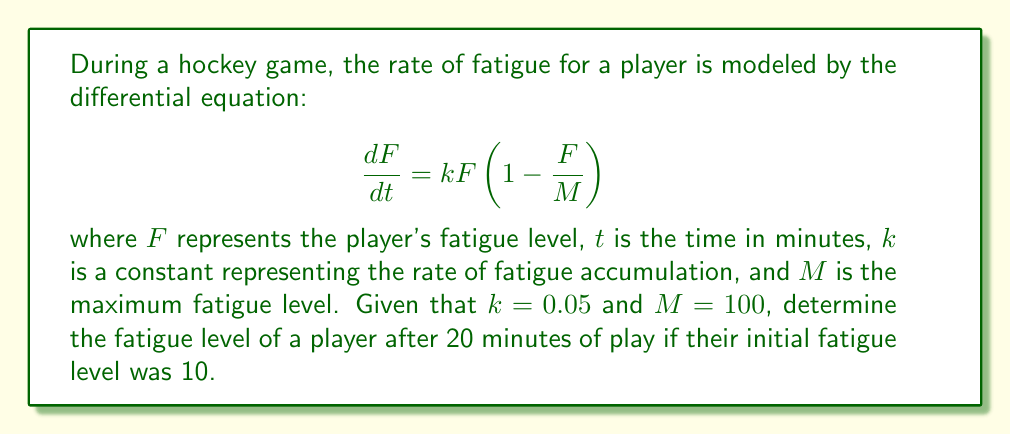Provide a solution to this math problem. To solve this problem, we need to use the given first-order differential equation and apply the separation of variables method:

1) First, let's separate the variables:
   $$ \frac{dF}{F(1-\frac{F}{M})} = k dt $$

2) Integrate both sides:
   $$ \int \frac{dF}{F(1-\frac{F}{M})} = \int k dt $$

3) The left side can be integrated using partial fractions:
   $$ \ln|F| - \ln|M-F| = kt + C $$

4) Simplify:
   $$ \ln|\frac{F}{M-F}| = kt + C $$

5) Exponentiate both sides:
   $$ \frac{F}{M-F} = Ce^{kt} $$

6) Solve for $F$:
   $$ F = \frac{MCe^{kt}}{1+Ce^{kt}} $$

7) Use the initial condition $F(0) = 10$ to find $C$:
   $$ 10 = \frac{100C}{1+C} $$
   $$ C = \frac{1}{9} $$

8) Now we have the particular solution:
   $$ F = \frac{100(\frac{1}{9})e^{0.05t}}{1+(\frac{1}{9})e^{0.05t}} $$

9) To find $F(20)$, substitute $t=20$:
   $$ F(20) = \frac{100(\frac{1}{9})e^{1}}{1+(\frac{1}{9})e^{1}} \approx 37.8 $$

Therefore, after 20 minutes of play, the player's fatigue level will be approximately 37.8.
Answer: $F(20) \approx 37.8$ 